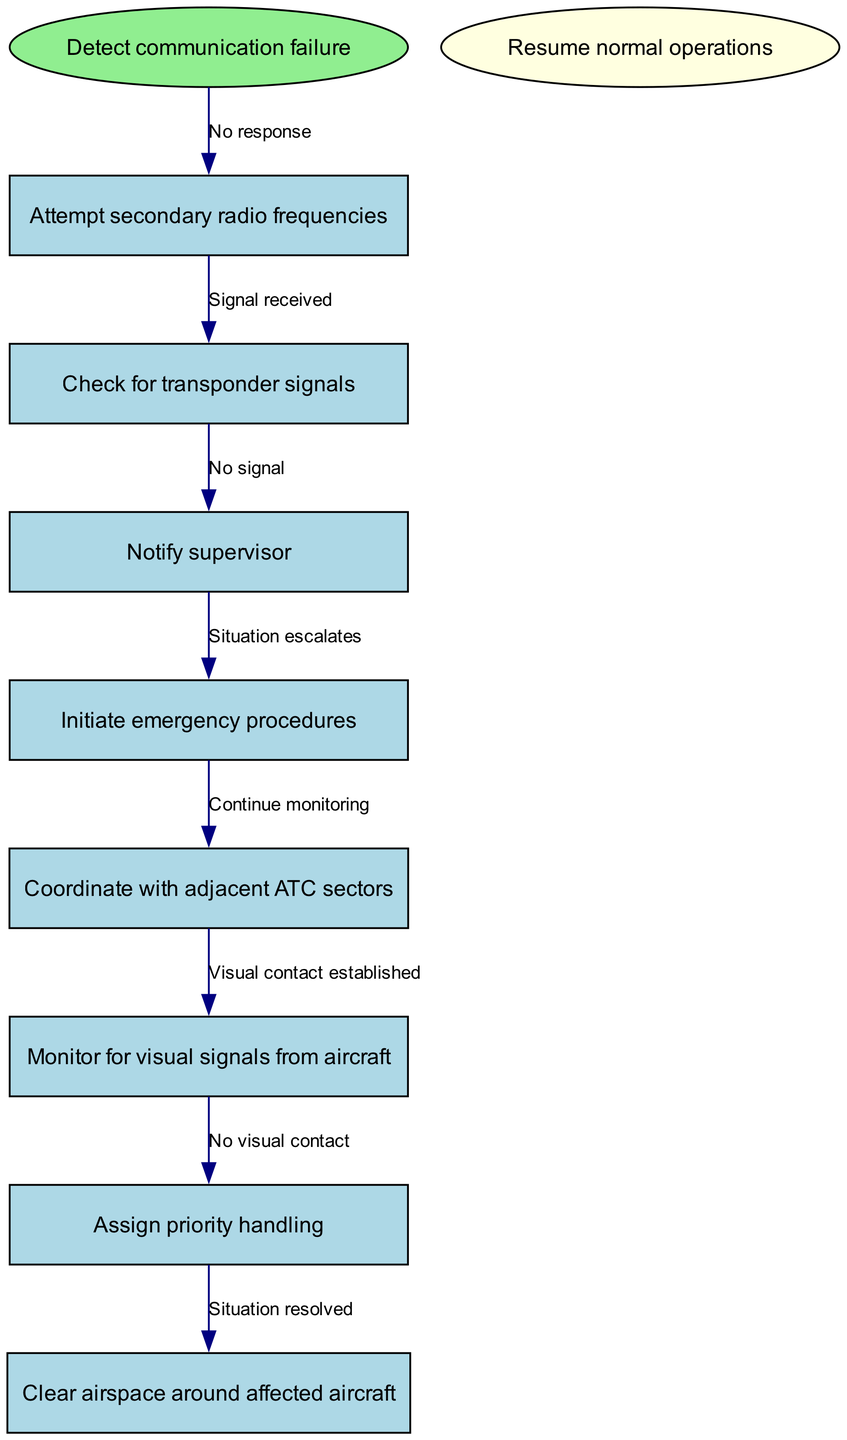What is the first action taken after detecting a communication failure? The diagram indicates that the first action taken is to "Attempt secondary radio frequencies" right after the "Detect communication failure" node.
Answer: Attempt secondary radio frequencies How many nodes are there in total? The total number of nodes includes the start node, end node, and all other action nodes, totaling 9.
Answer: 9 What happens if there is no response from the secondary frequency? If there is "No response," the flow pushes towards "Check for transponder signals," indicating the next action after failure to communicate via secondary frequencies.
Answer: Check for transponder signals What is the last step in the procedure? According to the diagram, the last step in the procedure is to "Resume normal operations," indicating the conclusion of actions taken during a communication failure.
Answer: Resume normal operations If a visual contact is established, what is the next action? Establishing "Visual contact" means that the following step would typically be related to monitoring or confirming safety, potentially implying the situation is closer to resolution. However, the next node was not indicated, but this suggests moving toward resolving the situation.
Answer: Situation resolved What action is taken if there is no signal from the transponder? In the case of "No signal," the procedure advances to "Initiate emergency procedures," indicating the severity of the situation prompts immediate escalation.
Answer: Initiate emergency procedures How is priority handling assigned? The assignment of "Priority handling" follows the notification of the supervisor once adequate communication failure adjustments are made since it suggests urgency.
Answer: After notifying supervisor What is the primary purpose of checking for transponder signals? Checking for transponder signals serves as an additional verification method to determine the aircraft's situation and maintain safety in the absence of radio communication, enhancing situational awareness.
Answer: To determine the aircraft's situation 